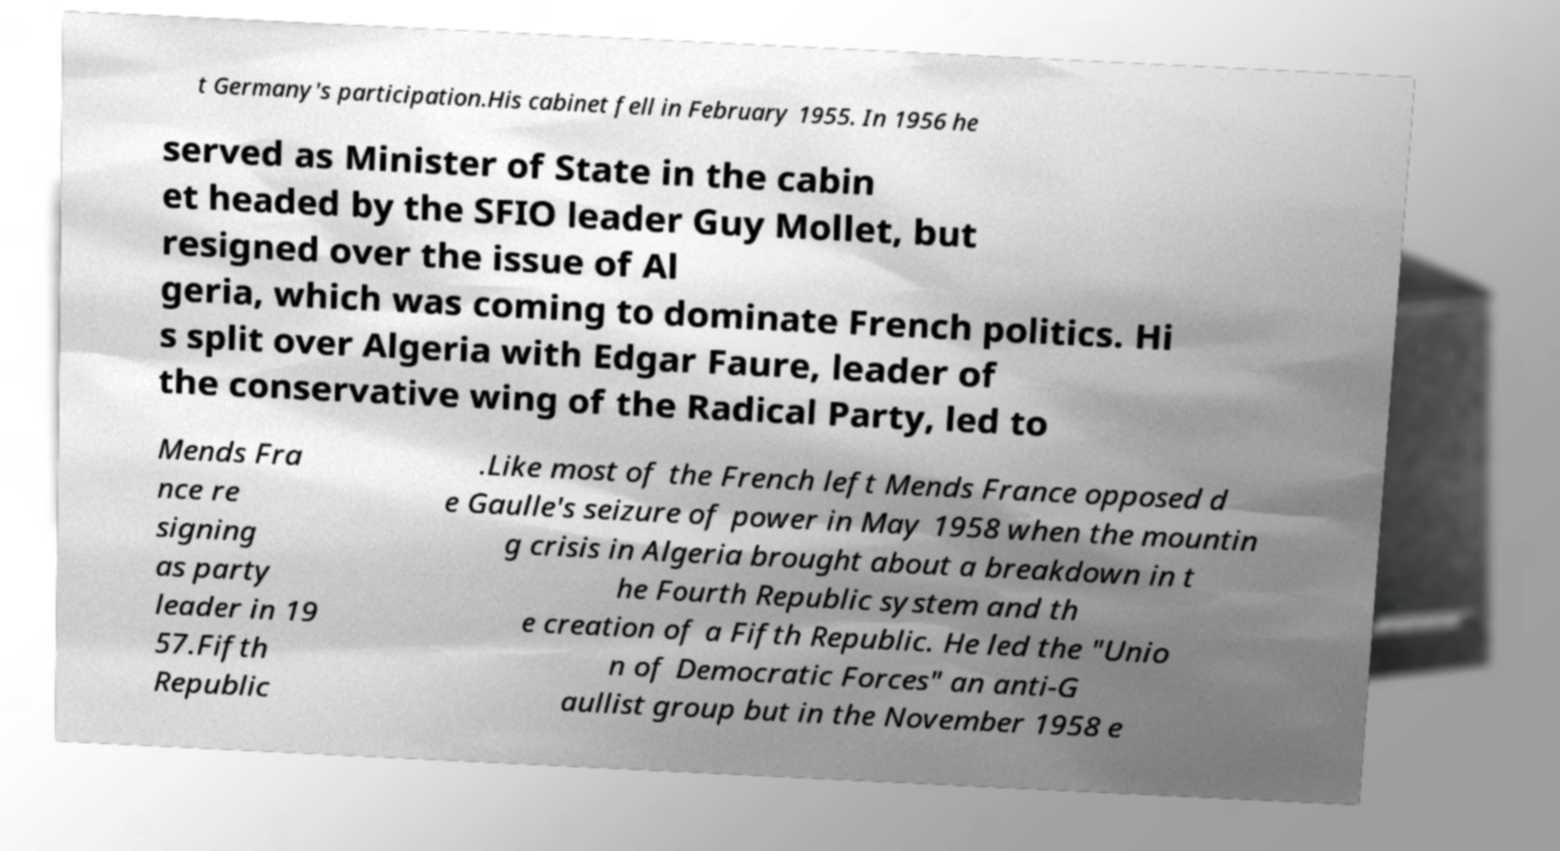Could you assist in decoding the text presented in this image and type it out clearly? t Germany's participation.His cabinet fell in February 1955. In 1956 he served as Minister of State in the cabin et headed by the SFIO leader Guy Mollet, but resigned over the issue of Al geria, which was coming to dominate French politics. Hi s split over Algeria with Edgar Faure, leader of the conservative wing of the Radical Party, led to Mends Fra nce re signing as party leader in 19 57.Fifth Republic .Like most of the French left Mends France opposed d e Gaulle's seizure of power in May 1958 when the mountin g crisis in Algeria brought about a breakdown in t he Fourth Republic system and th e creation of a Fifth Republic. He led the "Unio n of Democratic Forces" an anti-G aullist group but in the November 1958 e 